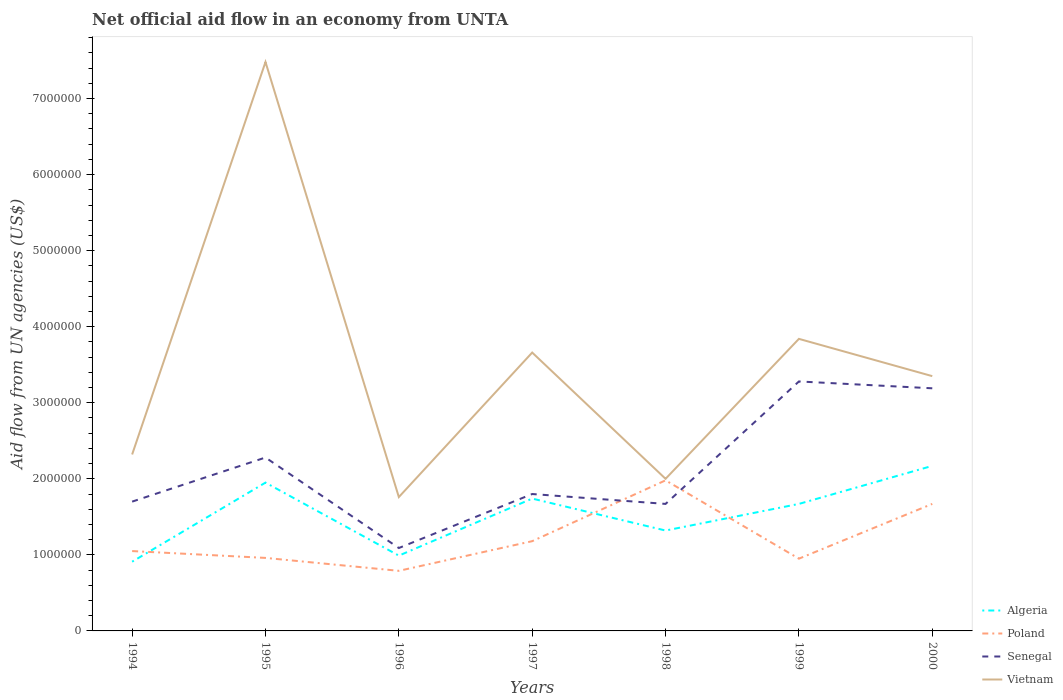Across all years, what is the maximum net official aid flow in Vietnam?
Give a very brief answer. 1.76e+06. In which year was the net official aid flow in Vietnam maximum?
Your answer should be compact. 1996. What is the total net official aid flow in Senegal in the graph?
Provide a short and direct response. -1.58e+06. What is the difference between the highest and the second highest net official aid flow in Algeria?
Offer a very short reply. 1.26e+06. What is the difference between two consecutive major ticks on the Y-axis?
Offer a terse response. 1.00e+06. Are the values on the major ticks of Y-axis written in scientific E-notation?
Offer a terse response. No. Does the graph contain any zero values?
Your response must be concise. No. Where does the legend appear in the graph?
Provide a succinct answer. Bottom right. How are the legend labels stacked?
Provide a succinct answer. Vertical. What is the title of the graph?
Provide a succinct answer. Net official aid flow in an economy from UNTA. What is the label or title of the X-axis?
Offer a very short reply. Years. What is the label or title of the Y-axis?
Keep it short and to the point. Aid flow from UN agencies (US$). What is the Aid flow from UN agencies (US$) of Algeria in 1994?
Ensure brevity in your answer.  9.10e+05. What is the Aid flow from UN agencies (US$) of Poland in 1994?
Give a very brief answer. 1.05e+06. What is the Aid flow from UN agencies (US$) in Senegal in 1994?
Offer a very short reply. 1.70e+06. What is the Aid flow from UN agencies (US$) in Vietnam in 1994?
Ensure brevity in your answer.  2.32e+06. What is the Aid flow from UN agencies (US$) of Algeria in 1995?
Your response must be concise. 1.95e+06. What is the Aid flow from UN agencies (US$) in Poland in 1995?
Offer a terse response. 9.60e+05. What is the Aid flow from UN agencies (US$) in Senegal in 1995?
Offer a very short reply. 2.28e+06. What is the Aid flow from UN agencies (US$) in Vietnam in 1995?
Offer a terse response. 7.48e+06. What is the Aid flow from UN agencies (US$) in Algeria in 1996?
Your answer should be compact. 9.90e+05. What is the Aid flow from UN agencies (US$) of Poland in 1996?
Keep it short and to the point. 7.90e+05. What is the Aid flow from UN agencies (US$) in Senegal in 1996?
Your answer should be very brief. 1.09e+06. What is the Aid flow from UN agencies (US$) of Vietnam in 1996?
Provide a short and direct response. 1.76e+06. What is the Aid flow from UN agencies (US$) of Algeria in 1997?
Offer a terse response. 1.74e+06. What is the Aid flow from UN agencies (US$) in Poland in 1997?
Keep it short and to the point. 1.18e+06. What is the Aid flow from UN agencies (US$) in Senegal in 1997?
Your answer should be very brief. 1.80e+06. What is the Aid flow from UN agencies (US$) in Vietnam in 1997?
Offer a very short reply. 3.66e+06. What is the Aid flow from UN agencies (US$) of Algeria in 1998?
Your answer should be very brief. 1.32e+06. What is the Aid flow from UN agencies (US$) in Poland in 1998?
Make the answer very short. 1.98e+06. What is the Aid flow from UN agencies (US$) of Senegal in 1998?
Give a very brief answer. 1.67e+06. What is the Aid flow from UN agencies (US$) of Algeria in 1999?
Your answer should be compact. 1.67e+06. What is the Aid flow from UN agencies (US$) of Poland in 1999?
Provide a succinct answer. 9.50e+05. What is the Aid flow from UN agencies (US$) in Senegal in 1999?
Keep it short and to the point. 3.28e+06. What is the Aid flow from UN agencies (US$) of Vietnam in 1999?
Provide a succinct answer. 3.84e+06. What is the Aid flow from UN agencies (US$) of Algeria in 2000?
Keep it short and to the point. 2.17e+06. What is the Aid flow from UN agencies (US$) in Poland in 2000?
Make the answer very short. 1.67e+06. What is the Aid flow from UN agencies (US$) of Senegal in 2000?
Ensure brevity in your answer.  3.19e+06. What is the Aid flow from UN agencies (US$) in Vietnam in 2000?
Give a very brief answer. 3.35e+06. Across all years, what is the maximum Aid flow from UN agencies (US$) of Algeria?
Your response must be concise. 2.17e+06. Across all years, what is the maximum Aid flow from UN agencies (US$) of Poland?
Offer a terse response. 1.98e+06. Across all years, what is the maximum Aid flow from UN agencies (US$) of Senegal?
Your answer should be compact. 3.28e+06. Across all years, what is the maximum Aid flow from UN agencies (US$) of Vietnam?
Offer a terse response. 7.48e+06. Across all years, what is the minimum Aid flow from UN agencies (US$) of Algeria?
Your answer should be compact. 9.10e+05. Across all years, what is the minimum Aid flow from UN agencies (US$) in Poland?
Your answer should be compact. 7.90e+05. Across all years, what is the minimum Aid flow from UN agencies (US$) of Senegal?
Your answer should be very brief. 1.09e+06. Across all years, what is the minimum Aid flow from UN agencies (US$) in Vietnam?
Give a very brief answer. 1.76e+06. What is the total Aid flow from UN agencies (US$) in Algeria in the graph?
Make the answer very short. 1.08e+07. What is the total Aid flow from UN agencies (US$) of Poland in the graph?
Ensure brevity in your answer.  8.58e+06. What is the total Aid flow from UN agencies (US$) of Senegal in the graph?
Make the answer very short. 1.50e+07. What is the total Aid flow from UN agencies (US$) in Vietnam in the graph?
Keep it short and to the point. 2.44e+07. What is the difference between the Aid flow from UN agencies (US$) in Algeria in 1994 and that in 1995?
Ensure brevity in your answer.  -1.04e+06. What is the difference between the Aid flow from UN agencies (US$) of Senegal in 1994 and that in 1995?
Provide a short and direct response. -5.80e+05. What is the difference between the Aid flow from UN agencies (US$) of Vietnam in 1994 and that in 1995?
Offer a terse response. -5.16e+06. What is the difference between the Aid flow from UN agencies (US$) in Algeria in 1994 and that in 1996?
Offer a very short reply. -8.00e+04. What is the difference between the Aid flow from UN agencies (US$) of Poland in 1994 and that in 1996?
Provide a short and direct response. 2.60e+05. What is the difference between the Aid flow from UN agencies (US$) in Vietnam in 1994 and that in 1996?
Your answer should be compact. 5.60e+05. What is the difference between the Aid flow from UN agencies (US$) in Algeria in 1994 and that in 1997?
Give a very brief answer. -8.30e+05. What is the difference between the Aid flow from UN agencies (US$) of Poland in 1994 and that in 1997?
Provide a short and direct response. -1.30e+05. What is the difference between the Aid flow from UN agencies (US$) in Vietnam in 1994 and that in 1997?
Keep it short and to the point. -1.34e+06. What is the difference between the Aid flow from UN agencies (US$) of Algeria in 1994 and that in 1998?
Provide a succinct answer. -4.10e+05. What is the difference between the Aid flow from UN agencies (US$) in Poland in 1994 and that in 1998?
Give a very brief answer. -9.30e+05. What is the difference between the Aid flow from UN agencies (US$) of Vietnam in 1994 and that in 1998?
Give a very brief answer. 3.20e+05. What is the difference between the Aid flow from UN agencies (US$) of Algeria in 1994 and that in 1999?
Provide a succinct answer. -7.60e+05. What is the difference between the Aid flow from UN agencies (US$) in Poland in 1994 and that in 1999?
Provide a short and direct response. 1.00e+05. What is the difference between the Aid flow from UN agencies (US$) of Senegal in 1994 and that in 1999?
Ensure brevity in your answer.  -1.58e+06. What is the difference between the Aid flow from UN agencies (US$) of Vietnam in 1994 and that in 1999?
Offer a very short reply. -1.52e+06. What is the difference between the Aid flow from UN agencies (US$) of Algeria in 1994 and that in 2000?
Your answer should be compact. -1.26e+06. What is the difference between the Aid flow from UN agencies (US$) of Poland in 1994 and that in 2000?
Offer a terse response. -6.20e+05. What is the difference between the Aid flow from UN agencies (US$) of Senegal in 1994 and that in 2000?
Keep it short and to the point. -1.49e+06. What is the difference between the Aid flow from UN agencies (US$) in Vietnam in 1994 and that in 2000?
Give a very brief answer. -1.03e+06. What is the difference between the Aid flow from UN agencies (US$) of Algeria in 1995 and that in 1996?
Your answer should be compact. 9.60e+05. What is the difference between the Aid flow from UN agencies (US$) in Poland in 1995 and that in 1996?
Your answer should be compact. 1.70e+05. What is the difference between the Aid flow from UN agencies (US$) in Senegal in 1995 and that in 1996?
Your response must be concise. 1.19e+06. What is the difference between the Aid flow from UN agencies (US$) of Vietnam in 1995 and that in 1996?
Provide a short and direct response. 5.72e+06. What is the difference between the Aid flow from UN agencies (US$) in Algeria in 1995 and that in 1997?
Provide a short and direct response. 2.10e+05. What is the difference between the Aid flow from UN agencies (US$) in Poland in 1995 and that in 1997?
Your response must be concise. -2.20e+05. What is the difference between the Aid flow from UN agencies (US$) of Senegal in 1995 and that in 1997?
Ensure brevity in your answer.  4.80e+05. What is the difference between the Aid flow from UN agencies (US$) of Vietnam in 1995 and that in 1997?
Give a very brief answer. 3.82e+06. What is the difference between the Aid flow from UN agencies (US$) in Algeria in 1995 and that in 1998?
Ensure brevity in your answer.  6.30e+05. What is the difference between the Aid flow from UN agencies (US$) of Poland in 1995 and that in 1998?
Your response must be concise. -1.02e+06. What is the difference between the Aid flow from UN agencies (US$) in Senegal in 1995 and that in 1998?
Make the answer very short. 6.10e+05. What is the difference between the Aid flow from UN agencies (US$) of Vietnam in 1995 and that in 1998?
Ensure brevity in your answer.  5.48e+06. What is the difference between the Aid flow from UN agencies (US$) of Algeria in 1995 and that in 1999?
Your answer should be compact. 2.80e+05. What is the difference between the Aid flow from UN agencies (US$) in Poland in 1995 and that in 1999?
Provide a succinct answer. 10000. What is the difference between the Aid flow from UN agencies (US$) of Vietnam in 1995 and that in 1999?
Your answer should be compact. 3.64e+06. What is the difference between the Aid flow from UN agencies (US$) of Poland in 1995 and that in 2000?
Provide a succinct answer. -7.10e+05. What is the difference between the Aid flow from UN agencies (US$) of Senegal in 1995 and that in 2000?
Ensure brevity in your answer.  -9.10e+05. What is the difference between the Aid flow from UN agencies (US$) in Vietnam in 1995 and that in 2000?
Provide a short and direct response. 4.13e+06. What is the difference between the Aid flow from UN agencies (US$) in Algeria in 1996 and that in 1997?
Offer a terse response. -7.50e+05. What is the difference between the Aid flow from UN agencies (US$) of Poland in 1996 and that in 1997?
Make the answer very short. -3.90e+05. What is the difference between the Aid flow from UN agencies (US$) in Senegal in 1996 and that in 1997?
Offer a very short reply. -7.10e+05. What is the difference between the Aid flow from UN agencies (US$) of Vietnam in 1996 and that in 1997?
Keep it short and to the point. -1.90e+06. What is the difference between the Aid flow from UN agencies (US$) of Algeria in 1996 and that in 1998?
Ensure brevity in your answer.  -3.30e+05. What is the difference between the Aid flow from UN agencies (US$) of Poland in 1996 and that in 1998?
Provide a short and direct response. -1.19e+06. What is the difference between the Aid flow from UN agencies (US$) in Senegal in 1996 and that in 1998?
Offer a terse response. -5.80e+05. What is the difference between the Aid flow from UN agencies (US$) in Algeria in 1996 and that in 1999?
Make the answer very short. -6.80e+05. What is the difference between the Aid flow from UN agencies (US$) of Poland in 1996 and that in 1999?
Provide a succinct answer. -1.60e+05. What is the difference between the Aid flow from UN agencies (US$) of Senegal in 1996 and that in 1999?
Your answer should be very brief. -2.19e+06. What is the difference between the Aid flow from UN agencies (US$) of Vietnam in 1996 and that in 1999?
Offer a very short reply. -2.08e+06. What is the difference between the Aid flow from UN agencies (US$) in Algeria in 1996 and that in 2000?
Provide a succinct answer. -1.18e+06. What is the difference between the Aid flow from UN agencies (US$) of Poland in 1996 and that in 2000?
Give a very brief answer. -8.80e+05. What is the difference between the Aid flow from UN agencies (US$) in Senegal in 1996 and that in 2000?
Offer a terse response. -2.10e+06. What is the difference between the Aid flow from UN agencies (US$) of Vietnam in 1996 and that in 2000?
Make the answer very short. -1.59e+06. What is the difference between the Aid flow from UN agencies (US$) in Poland in 1997 and that in 1998?
Make the answer very short. -8.00e+05. What is the difference between the Aid flow from UN agencies (US$) of Senegal in 1997 and that in 1998?
Offer a very short reply. 1.30e+05. What is the difference between the Aid flow from UN agencies (US$) in Vietnam in 1997 and that in 1998?
Make the answer very short. 1.66e+06. What is the difference between the Aid flow from UN agencies (US$) in Algeria in 1997 and that in 1999?
Provide a short and direct response. 7.00e+04. What is the difference between the Aid flow from UN agencies (US$) of Senegal in 1997 and that in 1999?
Offer a terse response. -1.48e+06. What is the difference between the Aid flow from UN agencies (US$) of Algeria in 1997 and that in 2000?
Provide a short and direct response. -4.30e+05. What is the difference between the Aid flow from UN agencies (US$) of Poland in 1997 and that in 2000?
Your answer should be very brief. -4.90e+05. What is the difference between the Aid flow from UN agencies (US$) in Senegal in 1997 and that in 2000?
Your answer should be compact. -1.39e+06. What is the difference between the Aid flow from UN agencies (US$) in Vietnam in 1997 and that in 2000?
Your response must be concise. 3.10e+05. What is the difference between the Aid flow from UN agencies (US$) of Algeria in 1998 and that in 1999?
Keep it short and to the point. -3.50e+05. What is the difference between the Aid flow from UN agencies (US$) in Poland in 1998 and that in 1999?
Offer a terse response. 1.03e+06. What is the difference between the Aid flow from UN agencies (US$) of Senegal in 1998 and that in 1999?
Your response must be concise. -1.61e+06. What is the difference between the Aid flow from UN agencies (US$) in Vietnam in 1998 and that in 1999?
Provide a succinct answer. -1.84e+06. What is the difference between the Aid flow from UN agencies (US$) in Algeria in 1998 and that in 2000?
Offer a terse response. -8.50e+05. What is the difference between the Aid flow from UN agencies (US$) of Poland in 1998 and that in 2000?
Your answer should be very brief. 3.10e+05. What is the difference between the Aid flow from UN agencies (US$) of Senegal in 1998 and that in 2000?
Offer a terse response. -1.52e+06. What is the difference between the Aid flow from UN agencies (US$) of Vietnam in 1998 and that in 2000?
Give a very brief answer. -1.35e+06. What is the difference between the Aid flow from UN agencies (US$) of Algeria in 1999 and that in 2000?
Offer a very short reply. -5.00e+05. What is the difference between the Aid flow from UN agencies (US$) of Poland in 1999 and that in 2000?
Your answer should be very brief. -7.20e+05. What is the difference between the Aid flow from UN agencies (US$) of Senegal in 1999 and that in 2000?
Give a very brief answer. 9.00e+04. What is the difference between the Aid flow from UN agencies (US$) of Vietnam in 1999 and that in 2000?
Keep it short and to the point. 4.90e+05. What is the difference between the Aid flow from UN agencies (US$) in Algeria in 1994 and the Aid flow from UN agencies (US$) in Poland in 1995?
Give a very brief answer. -5.00e+04. What is the difference between the Aid flow from UN agencies (US$) of Algeria in 1994 and the Aid flow from UN agencies (US$) of Senegal in 1995?
Make the answer very short. -1.37e+06. What is the difference between the Aid flow from UN agencies (US$) in Algeria in 1994 and the Aid flow from UN agencies (US$) in Vietnam in 1995?
Ensure brevity in your answer.  -6.57e+06. What is the difference between the Aid flow from UN agencies (US$) in Poland in 1994 and the Aid flow from UN agencies (US$) in Senegal in 1995?
Provide a succinct answer. -1.23e+06. What is the difference between the Aid flow from UN agencies (US$) of Poland in 1994 and the Aid flow from UN agencies (US$) of Vietnam in 1995?
Ensure brevity in your answer.  -6.43e+06. What is the difference between the Aid flow from UN agencies (US$) of Senegal in 1994 and the Aid flow from UN agencies (US$) of Vietnam in 1995?
Provide a short and direct response. -5.78e+06. What is the difference between the Aid flow from UN agencies (US$) in Algeria in 1994 and the Aid flow from UN agencies (US$) in Vietnam in 1996?
Keep it short and to the point. -8.50e+05. What is the difference between the Aid flow from UN agencies (US$) of Poland in 1994 and the Aid flow from UN agencies (US$) of Vietnam in 1996?
Keep it short and to the point. -7.10e+05. What is the difference between the Aid flow from UN agencies (US$) in Algeria in 1994 and the Aid flow from UN agencies (US$) in Senegal in 1997?
Your response must be concise. -8.90e+05. What is the difference between the Aid flow from UN agencies (US$) of Algeria in 1994 and the Aid flow from UN agencies (US$) of Vietnam in 1997?
Keep it short and to the point. -2.75e+06. What is the difference between the Aid flow from UN agencies (US$) of Poland in 1994 and the Aid flow from UN agencies (US$) of Senegal in 1997?
Provide a succinct answer. -7.50e+05. What is the difference between the Aid flow from UN agencies (US$) of Poland in 1994 and the Aid flow from UN agencies (US$) of Vietnam in 1997?
Give a very brief answer. -2.61e+06. What is the difference between the Aid flow from UN agencies (US$) of Senegal in 1994 and the Aid flow from UN agencies (US$) of Vietnam in 1997?
Your answer should be very brief. -1.96e+06. What is the difference between the Aid flow from UN agencies (US$) of Algeria in 1994 and the Aid flow from UN agencies (US$) of Poland in 1998?
Offer a terse response. -1.07e+06. What is the difference between the Aid flow from UN agencies (US$) of Algeria in 1994 and the Aid flow from UN agencies (US$) of Senegal in 1998?
Make the answer very short. -7.60e+05. What is the difference between the Aid flow from UN agencies (US$) of Algeria in 1994 and the Aid flow from UN agencies (US$) of Vietnam in 1998?
Keep it short and to the point. -1.09e+06. What is the difference between the Aid flow from UN agencies (US$) in Poland in 1994 and the Aid flow from UN agencies (US$) in Senegal in 1998?
Your answer should be very brief. -6.20e+05. What is the difference between the Aid flow from UN agencies (US$) in Poland in 1994 and the Aid flow from UN agencies (US$) in Vietnam in 1998?
Your response must be concise. -9.50e+05. What is the difference between the Aid flow from UN agencies (US$) of Senegal in 1994 and the Aid flow from UN agencies (US$) of Vietnam in 1998?
Your answer should be very brief. -3.00e+05. What is the difference between the Aid flow from UN agencies (US$) of Algeria in 1994 and the Aid flow from UN agencies (US$) of Senegal in 1999?
Offer a terse response. -2.37e+06. What is the difference between the Aid flow from UN agencies (US$) of Algeria in 1994 and the Aid flow from UN agencies (US$) of Vietnam in 1999?
Provide a succinct answer. -2.93e+06. What is the difference between the Aid flow from UN agencies (US$) of Poland in 1994 and the Aid flow from UN agencies (US$) of Senegal in 1999?
Your answer should be compact. -2.23e+06. What is the difference between the Aid flow from UN agencies (US$) of Poland in 1994 and the Aid flow from UN agencies (US$) of Vietnam in 1999?
Give a very brief answer. -2.79e+06. What is the difference between the Aid flow from UN agencies (US$) of Senegal in 1994 and the Aid flow from UN agencies (US$) of Vietnam in 1999?
Offer a terse response. -2.14e+06. What is the difference between the Aid flow from UN agencies (US$) of Algeria in 1994 and the Aid flow from UN agencies (US$) of Poland in 2000?
Offer a terse response. -7.60e+05. What is the difference between the Aid flow from UN agencies (US$) in Algeria in 1994 and the Aid flow from UN agencies (US$) in Senegal in 2000?
Provide a succinct answer. -2.28e+06. What is the difference between the Aid flow from UN agencies (US$) of Algeria in 1994 and the Aid flow from UN agencies (US$) of Vietnam in 2000?
Offer a terse response. -2.44e+06. What is the difference between the Aid flow from UN agencies (US$) in Poland in 1994 and the Aid flow from UN agencies (US$) in Senegal in 2000?
Provide a succinct answer. -2.14e+06. What is the difference between the Aid flow from UN agencies (US$) in Poland in 1994 and the Aid flow from UN agencies (US$) in Vietnam in 2000?
Ensure brevity in your answer.  -2.30e+06. What is the difference between the Aid flow from UN agencies (US$) of Senegal in 1994 and the Aid flow from UN agencies (US$) of Vietnam in 2000?
Provide a succinct answer. -1.65e+06. What is the difference between the Aid flow from UN agencies (US$) in Algeria in 1995 and the Aid flow from UN agencies (US$) in Poland in 1996?
Make the answer very short. 1.16e+06. What is the difference between the Aid flow from UN agencies (US$) of Algeria in 1995 and the Aid flow from UN agencies (US$) of Senegal in 1996?
Your answer should be very brief. 8.60e+05. What is the difference between the Aid flow from UN agencies (US$) in Algeria in 1995 and the Aid flow from UN agencies (US$) in Vietnam in 1996?
Your answer should be very brief. 1.90e+05. What is the difference between the Aid flow from UN agencies (US$) in Poland in 1995 and the Aid flow from UN agencies (US$) in Vietnam in 1996?
Provide a short and direct response. -8.00e+05. What is the difference between the Aid flow from UN agencies (US$) of Senegal in 1995 and the Aid flow from UN agencies (US$) of Vietnam in 1996?
Give a very brief answer. 5.20e+05. What is the difference between the Aid flow from UN agencies (US$) of Algeria in 1995 and the Aid flow from UN agencies (US$) of Poland in 1997?
Provide a succinct answer. 7.70e+05. What is the difference between the Aid flow from UN agencies (US$) of Algeria in 1995 and the Aid flow from UN agencies (US$) of Senegal in 1997?
Offer a terse response. 1.50e+05. What is the difference between the Aid flow from UN agencies (US$) in Algeria in 1995 and the Aid flow from UN agencies (US$) in Vietnam in 1997?
Keep it short and to the point. -1.71e+06. What is the difference between the Aid flow from UN agencies (US$) in Poland in 1995 and the Aid flow from UN agencies (US$) in Senegal in 1997?
Ensure brevity in your answer.  -8.40e+05. What is the difference between the Aid flow from UN agencies (US$) in Poland in 1995 and the Aid flow from UN agencies (US$) in Vietnam in 1997?
Offer a terse response. -2.70e+06. What is the difference between the Aid flow from UN agencies (US$) in Senegal in 1995 and the Aid flow from UN agencies (US$) in Vietnam in 1997?
Make the answer very short. -1.38e+06. What is the difference between the Aid flow from UN agencies (US$) in Algeria in 1995 and the Aid flow from UN agencies (US$) in Senegal in 1998?
Provide a succinct answer. 2.80e+05. What is the difference between the Aid flow from UN agencies (US$) in Algeria in 1995 and the Aid flow from UN agencies (US$) in Vietnam in 1998?
Your response must be concise. -5.00e+04. What is the difference between the Aid flow from UN agencies (US$) of Poland in 1995 and the Aid flow from UN agencies (US$) of Senegal in 1998?
Provide a short and direct response. -7.10e+05. What is the difference between the Aid flow from UN agencies (US$) of Poland in 1995 and the Aid flow from UN agencies (US$) of Vietnam in 1998?
Your response must be concise. -1.04e+06. What is the difference between the Aid flow from UN agencies (US$) in Algeria in 1995 and the Aid flow from UN agencies (US$) in Senegal in 1999?
Make the answer very short. -1.33e+06. What is the difference between the Aid flow from UN agencies (US$) in Algeria in 1995 and the Aid flow from UN agencies (US$) in Vietnam in 1999?
Your answer should be very brief. -1.89e+06. What is the difference between the Aid flow from UN agencies (US$) of Poland in 1995 and the Aid flow from UN agencies (US$) of Senegal in 1999?
Provide a succinct answer. -2.32e+06. What is the difference between the Aid flow from UN agencies (US$) in Poland in 1995 and the Aid flow from UN agencies (US$) in Vietnam in 1999?
Offer a terse response. -2.88e+06. What is the difference between the Aid flow from UN agencies (US$) in Senegal in 1995 and the Aid flow from UN agencies (US$) in Vietnam in 1999?
Provide a succinct answer. -1.56e+06. What is the difference between the Aid flow from UN agencies (US$) of Algeria in 1995 and the Aid flow from UN agencies (US$) of Poland in 2000?
Your answer should be compact. 2.80e+05. What is the difference between the Aid flow from UN agencies (US$) of Algeria in 1995 and the Aid flow from UN agencies (US$) of Senegal in 2000?
Your response must be concise. -1.24e+06. What is the difference between the Aid flow from UN agencies (US$) of Algeria in 1995 and the Aid flow from UN agencies (US$) of Vietnam in 2000?
Keep it short and to the point. -1.40e+06. What is the difference between the Aid flow from UN agencies (US$) of Poland in 1995 and the Aid flow from UN agencies (US$) of Senegal in 2000?
Provide a succinct answer. -2.23e+06. What is the difference between the Aid flow from UN agencies (US$) of Poland in 1995 and the Aid flow from UN agencies (US$) of Vietnam in 2000?
Provide a succinct answer. -2.39e+06. What is the difference between the Aid flow from UN agencies (US$) of Senegal in 1995 and the Aid flow from UN agencies (US$) of Vietnam in 2000?
Offer a terse response. -1.07e+06. What is the difference between the Aid flow from UN agencies (US$) of Algeria in 1996 and the Aid flow from UN agencies (US$) of Senegal in 1997?
Your answer should be very brief. -8.10e+05. What is the difference between the Aid flow from UN agencies (US$) in Algeria in 1996 and the Aid flow from UN agencies (US$) in Vietnam in 1997?
Keep it short and to the point. -2.67e+06. What is the difference between the Aid flow from UN agencies (US$) of Poland in 1996 and the Aid flow from UN agencies (US$) of Senegal in 1997?
Offer a very short reply. -1.01e+06. What is the difference between the Aid flow from UN agencies (US$) of Poland in 1996 and the Aid flow from UN agencies (US$) of Vietnam in 1997?
Ensure brevity in your answer.  -2.87e+06. What is the difference between the Aid flow from UN agencies (US$) of Senegal in 1996 and the Aid flow from UN agencies (US$) of Vietnam in 1997?
Keep it short and to the point. -2.57e+06. What is the difference between the Aid flow from UN agencies (US$) in Algeria in 1996 and the Aid flow from UN agencies (US$) in Poland in 1998?
Offer a terse response. -9.90e+05. What is the difference between the Aid flow from UN agencies (US$) of Algeria in 1996 and the Aid flow from UN agencies (US$) of Senegal in 1998?
Make the answer very short. -6.80e+05. What is the difference between the Aid flow from UN agencies (US$) of Algeria in 1996 and the Aid flow from UN agencies (US$) of Vietnam in 1998?
Offer a very short reply. -1.01e+06. What is the difference between the Aid flow from UN agencies (US$) in Poland in 1996 and the Aid flow from UN agencies (US$) in Senegal in 1998?
Your answer should be very brief. -8.80e+05. What is the difference between the Aid flow from UN agencies (US$) in Poland in 1996 and the Aid flow from UN agencies (US$) in Vietnam in 1998?
Keep it short and to the point. -1.21e+06. What is the difference between the Aid flow from UN agencies (US$) in Senegal in 1996 and the Aid flow from UN agencies (US$) in Vietnam in 1998?
Your answer should be very brief. -9.10e+05. What is the difference between the Aid flow from UN agencies (US$) in Algeria in 1996 and the Aid flow from UN agencies (US$) in Poland in 1999?
Make the answer very short. 4.00e+04. What is the difference between the Aid flow from UN agencies (US$) in Algeria in 1996 and the Aid flow from UN agencies (US$) in Senegal in 1999?
Offer a terse response. -2.29e+06. What is the difference between the Aid flow from UN agencies (US$) of Algeria in 1996 and the Aid flow from UN agencies (US$) of Vietnam in 1999?
Offer a terse response. -2.85e+06. What is the difference between the Aid flow from UN agencies (US$) in Poland in 1996 and the Aid flow from UN agencies (US$) in Senegal in 1999?
Offer a terse response. -2.49e+06. What is the difference between the Aid flow from UN agencies (US$) in Poland in 1996 and the Aid flow from UN agencies (US$) in Vietnam in 1999?
Provide a succinct answer. -3.05e+06. What is the difference between the Aid flow from UN agencies (US$) in Senegal in 1996 and the Aid flow from UN agencies (US$) in Vietnam in 1999?
Ensure brevity in your answer.  -2.75e+06. What is the difference between the Aid flow from UN agencies (US$) in Algeria in 1996 and the Aid flow from UN agencies (US$) in Poland in 2000?
Provide a short and direct response. -6.80e+05. What is the difference between the Aid flow from UN agencies (US$) of Algeria in 1996 and the Aid flow from UN agencies (US$) of Senegal in 2000?
Make the answer very short. -2.20e+06. What is the difference between the Aid flow from UN agencies (US$) of Algeria in 1996 and the Aid flow from UN agencies (US$) of Vietnam in 2000?
Provide a short and direct response. -2.36e+06. What is the difference between the Aid flow from UN agencies (US$) of Poland in 1996 and the Aid flow from UN agencies (US$) of Senegal in 2000?
Make the answer very short. -2.40e+06. What is the difference between the Aid flow from UN agencies (US$) of Poland in 1996 and the Aid flow from UN agencies (US$) of Vietnam in 2000?
Offer a very short reply. -2.56e+06. What is the difference between the Aid flow from UN agencies (US$) in Senegal in 1996 and the Aid flow from UN agencies (US$) in Vietnam in 2000?
Give a very brief answer. -2.26e+06. What is the difference between the Aid flow from UN agencies (US$) in Algeria in 1997 and the Aid flow from UN agencies (US$) in Poland in 1998?
Give a very brief answer. -2.40e+05. What is the difference between the Aid flow from UN agencies (US$) in Poland in 1997 and the Aid flow from UN agencies (US$) in Senegal in 1998?
Your answer should be very brief. -4.90e+05. What is the difference between the Aid flow from UN agencies (US$) of Poland in 1997 and the Aid flow from UN agencies (US$) of Vietnam in 1998?
Your answer should be compact. -8.20e+05. What is the difference between the Aid flow from UN agencies (US$) in Algeria in 1997 and the Aid flow from UN agencies (US$) in Poland in 1999?
Offer a very short reply. 7.90e+05. What is the difference between the Aid flow from UN agencies (US$) in Algeria in 1997 and the Aid flow from UN agencies (US$) in Senegal in 1999?
Your answer should be compact. -1.54e+06. What is the difference between the Aid flow from UN agencies (US$) in Algeria in 1997 and the Aid flow from UN agencies (US$) in Vietnam in 1999?
Your answer should be very brief. -2.10e+06. What is the difference between the Aid flow from UN agencies (US$) of Poland in 1997 and the Aid flow from UN agencies (US$) of Senegal in 1999?
Ensure brevity in your answer.  -2.10e+06. What is the difference between the Aid flow from UN agencies (US$) in Poland in 1997 and the Aid flow from UN agencies (US$) in Vietnam in 1999?
Offer a very short reply. -2.66e+06. What is the difference between the Aid flow from UN agencies (US$) in Senegal in 1997 and the Aid flow from UN agencies (US$) in Vietnam in 1999?
Keep it short and to the point. -2.04e+06. What is the difference between the Aid flow from UN agencies (US$) of Algeria in 1997 and the Aid flow from UN agencies (US$) of Senegal in 2000?
Your answer should be compact. -1.45e+06. What is the difference between the Aid flow from UN agencies (US$) in Algeria in 1997 and the Aid flow from UN agencies (US$) in Vietnam in 2000?
Provide a succinct answer. -1.61e+06. What is the difference between the Aid flow from UN agencies (US$) of Poland in 1997 and the Aid flow from UN agencies (US$) of Senegal in 2000?
Your answer should be compact. -2.01e+06. What is the difference between the Aid flow from UN agencies (US$) in Poland in 1997 and the Aid flow from UN agencies (US$) in Vietnam in 2000?
Offer a very short reply. -2.17e+06. What is the difference between the Aid flow from UN agencies (US$) in Senegal in 1997 and the Aid flow from UN agencies (US$) in Vietnam in 2000?
Offer a very short reply. -1.55e+06. What is the difference between the Aid flow from UN agencies (US$) in Algeria in 1998 and the Aid flow from UN agencies (US$) in Senegal in 1999?
Your answer should be very brief. -1.96e+06. What is the difference between the Aid flow from UN agencies (US$) in Algeria in 1998 and the Aid flow from UN agencies (US$) in Vietnam in 1999?
Offer a terse response. -2.52e+06. What is the difference between the Aid flow from UN agencies (US$) of Poland in 1998 and the Aid flow from UN agencies (US$) of Senegal in 1999?
Make the answer very short. -1.30e+06. What is the difference between the Aid flow from UN agencies (US$) in Poland in 1998 and the Aid flow from UN agencies (US$) in Vietnam in 1999?
Your answer should be very brief. -1.86e+06. What is the difference between the Aid flow from UN agencies (US$) in Senegal in 1998 and the Aid flow from UN agencies (US$) in Vietnam in 1999?
Provide a short and direct response. -2.17e+06. What is the difference between the Aid flow from UN agencies (US$) of Algeria in 1998 and the Aid flow from UN agencies (US$) of Poland in 2000?
Provide a succinct answer. -3.50e+05. What is the difference between the Aid flow from UN agencies (US$) of Algeria in 1998 and the Aid flow from UN agencies (US$) of Senegal in 2000?
Offer a very short reply. -1.87e+06. What is the difference between the Aid flow from UN agencies (US$) in Algeria in 1998 and the Aid flow from UN agencies (US$) in Vietnam in 2000?
Provide a short and direct response. -2.03e+06. What is the difference between the Aid flow from UN agencies (US$) in Poland in 1998 and the Aid flow from UN agencies (US$) in Senegal in 2000?
Provide a short and direct response. -1.21e+06. What is the difference between the Aid flow from UN agencies (US$) of Poland in 1998 and the Aid flow from UN agencies (US$) of Vietnam in 2000?
Offer a very short reply. -1.37e+06. What is the difference between the Aid flow from UN agencies (US$) of Senegal in 1998 and the Aid flow from UN agencies (US$) of Vietnam in 2000?
Keep it short and to the point. -1.68e+06. What is the difference between the Aid flow from UN agencies (US$) in Algeria in 1999 and the Aid flow from UN agencies (US$) in Senegal in 2000?
Give a very brief answer. -1.52e+06. What is the difference between the Aid flow from UN agencies (US$) of Algeria in 1999 and the Aid flow from UN agencies (US$) of Vietnam in 2000?
Your answer should be compact. -1.68e+06. What is the difference between the Aid flow from UN agencies (US$) of Poland in 1999 and the Aid flow from UN agencies (US$) of Senegal in 2000?
Give a very brief answer. -2.24e+06. What is the difference between the Aid flow from UN agencies (US$) in Poland in 1999 and the Aid flow from UN agencies (US$) in Vietnam in 2000?
Offer a very short reply. -2.40e+06. What is the average Aid flow from UN agencies (US$) of Algeria per year?
Your answer should be very brief. 1.54e+06. What is the average Aid flow from UN agencies (US$) in Poland per year?
Provide a succinct answer. 1.23e+06. What is the average Aid flow from UN agencies (US$) of Senegal per year?
Keep it short and to the point. 2.14e+06. What is the average Aid flow from UN agencies (US$) in Vietnam per year?
Your response must be concise. 3.49e+06. In the year 1994, what is the difference between the Aid flow from UN agencies (US$) of Algeria and Aid flow from UN agencies (US$) of Poland?
Your answer should be compact. -1.40e+05. In the year 1994, what is the difference between the Aid flow from UN agencies (US$) in Algeria and Aid flow from UN agencies (US$) in Senegal?
Offer a terse response. -7.90e+05. In the year 1994, what is the difference between the Aid flow from UN agencies (US$) of Algeria and Aid flow from UN agencies (US$) of Vietnam?
Provide a short and direct response. -1.41e+06. In the year 1994, what is the difference between the Aid flow from UN agencies (US$) in Poland and Aid flow from UN agencies (US$) in Senegal?
Make the answer very short. -6.50e+05. In the year 1994, what is the difference between the Aid flow from UN agencies (US$) of Poland and Aid flow from UN agencies (US$) of Vietnam?
Provide a short and direct response. -1.27e+06. In the year 1994, what is the difference between the Aid flow from UN agencies (US$) in Senegal and Aid flow from UN agencies (US$) in Vietnam?
Give a very brief answer. -6.20e+05. In the year 1995, what is the difference between the Aid flow from UN agencies (US$) of Algeria and Aid flow from UN agencies (US$) of Poland?
Make the answer very short. 9.90e+05. In the year 1995, what is the difference between the Aid flow from UN agencies (US$) in Algeria and Aid flow from UN agencies (US$) in Senegal?
Provide a short and direct response. -3.30e+05. In the year 1995, what is the difference between the Aid flow from UN agencies (US$) of Algeria and Aid flow from UN agencies (US$) of Vietnam?
Your answer should be compact. -5.53e+06. In the year 1995, what is the difference between the Aid flow from UN agencies (US$) in Poland and Aid flow from UN agencies (US$) in Senegal?
Keep it short and to the point. -1.32e+06. In the year 1995, what is the difference between the Aid flow from UN agencies (US$) in Poland and Aid flow from UN agencies (US$) in Vietnam?
Your answer should be very brief. -6.52e+06. In the year 1995, what is the difference between the Aid flow from UN agencies (US$) in Senegal and Aid flow from UN agencies (US$) in Vietnam?
Your response must be concise. -5.20e+06. In the year 1996, what is the difference between the Aid flow from UN agencies (US$) in Algeria and Aid flow from UN agencies (US$) in Poland?
Provide a short and direct response. 2.00e+05. In the year 1996, what is the difference between the Aid flow from UN agencies (US$) of Algeria and Aid flow from UN agencies (US$) of Vietnam?
Ensure brevity in your answer.  -7.70e+05. In the year 1996, what is the difference between the Aid flow from UN agencies (US$) of Poland and Aid flow from UN agencies (US$) of Vietnam?
Offer a very short reply. -9.70e+05. In the year 1996, what is the difference between the Aid flow from UN agencies (US$) of Senegal and Aid flow from UN agencies (US$) of Vietnam?
Provide a succinct answer. -6.70e+05. In the year 1997, what is the difference between the Aid flow from UN agencies (US$) of Algeria and Aid flow from UN agencies (US$) of Poland?
Your answer should be compact. 5.60e+05. In the year 1997, what is the difference between the Aid flow from UN agencies (US$) in Algeria and Aid flow from UN agencies (US$) in Senegal?
Give a very brief answer. -6.00e+04. In the year 1997, what is the difference between the Aid flow from UN agencies (US$) of Algeria and Aid flow from UN agencies (US$) of Vietnam?
Your response must be concise. -1.92e+06. In the year 1997, what is the difference between the Aid flow from UN agencies (US$) of Poland and Aid flow from UN agencies (US$) of Senegal?
Ensure brevity in your answer.  -6.20e+05. In the year 1997, what is the difference between the Aid flow from UN agencies (US$) of Poland and Aid flow from UN agencies (US$) of Vietnam?
Provide a short and direct response. -2.48e+06. In the year 1997, what is the difference between the Aid flow from UN agencies (US$) of Senegal and Aid flow from UN agencies (US$) of Vietnam?
Your answer should be very brief. -1.86e+06. In the year 1998, what is the difference between the Aid flow from UN agencies (US$) in Algeria and Aid flow from UN agencies (US$) in Poland?
Make the answer very short. -6.60e+05. In the year 1998, what is the difference between the Aid flow from UN agencies (US$) in Algeria and Aid flow from UN agencies (US$) in Senegal?
Provide a short and direct response. -3.50e+05. In the year 1998, what is the difference between the Aid flow from UN agencies (US$) of Algeria and Aid flow from UN agencies (US$) of Vietnam?
Your answer should be very brief. -6.80e+05. In the year 1998, what is the difference between the Aid flow from UN agencies (US$) of Poland and Aid flow from UN agencies (US$) of Vietnam?
Your answer should be very brief. -2.00e+04. In the year 1998, what is the difference between the Aid flow from UN agencies (US$) in Senegal and Aid flow from UN agencies (US$) in Vietnam?
Provide a short and direct response. -3.30e+05. In the year 1999, what is the difference between the Aid flow from UN agencies (US$) in Algeria and Aid flow from UN agencies (US$) in Poland?
Make the answer very short. 7.20e+05. In the year 1999, what is the difference between the Aid flow from UN agencies (US$) in Algeria and Aid flow from UN agencies (US$) in Senegal?
Offer a very short reply. -1.61e+06. In the year 1999, what is the difference between the Aid flow from UN agencies (US$) of Algeria and Aid flow from UN agencies (US$) of Vietnam?
Keep it short and to the point. -2.17e+06. In the year 1999, what is the difference between the Aid flow from UN agencies (US$) of Poland and Aid flow from UN agencies (US$) of Senegal?
Give a very brief answer. -2.33e+06. In the year 1999, what is the difference between the Aid flow from UN agencies (US$) in Poland and Aid flow from UN agencies (US$) in Vietnam?
Your response must be concise. -2.89e+06. In the year 1999, what is the difference between the Aid flow from UN agencies (US$) of Senegal and Aid flow from UN agencies (US$) of Vietnam?
Offer a very short reply. -5.60e+05. In the year 2000, what is the difference between the Aid flow from UN agencies (US$) of Algeria and Aid flow from UN agencies (US$) of Poland?
Keep it short and to the point. 5.00e+05. In the year 2000, what is the difference between the Aid flow from UN agencies (US$) in Algeria and Aid flow from UN agencies (US$) in Senegal?
Offer a terse response. -1.02e+06. In the year 2000, what is the difference between the Aid flow from UN agencies (US$) of Algeria and Aid flow from UN agencies (US$) of Vietnam?
Your answer should be compact. -1.18e+06. In the year 2000, what is the difference between the Aid flow from UN agencies (US$) of Poland and Aid flow from UN agencies (US$) of Senegal?
Provide a short and direct response. -1.52e+06. In the year 2000, what is the difference between the Aid flow from UN agencies (US$) in Poland and Aid flow from UN agencies (US$) in Vietnam?
Ensure brevity in your answer.  -1.68e+06. In the year 2000, what is the difference between the Aid flow from UN agencies (US$) in Senegal and Aid flow from UN agencies (US$) in Vietnam?
Make the answer very short. -1.60e+05. What is the ratio of the Aid flow from UN agencies (US$) of Algeria in 1994 to that in 1995?
Offer a very short reply. 0.47. What is the ratio of the Aid flow from UN agencies (US$) in Poland in 1994 to that in 1995?
Provide a short and direct response. 1.09. What is the ratio of the Aid flow from UN agencies (US$) of Senegal in 1994 to that in 1995?
Give a very brief answer. 0.75. What is the ratio of the Aid flow from UN agencies (US$) in Vietnam in 1994 to that in 1995?
Your answer should be compact. 0.31. What is the ratio of the Aid flow from UN agencies (US$) in Algeria in 1994 to that in 1996?
Ensure brevity in your answer.  0.92. What is the ratio of the Aid flow from UN agencies (US$) of Poland in 1994 to that in 1996?
Make the answer very short. 1.33. What is the ratio of the Aid flow from UN agencies (US$) of Senegal in 1994 to that in 1996?
Keep it short and to the point. 1.56. What is the ratio of the Aid flow from UN agencies (US$) of Vietnam in 1994 to that in 1996?
Offer a very short reply. 1.32. What is the ratio of the Aid flow from UN agencies (US$) in Algeria in 1994 to that in 1997?
Your response must be concise. 0.52. What is the ratio of the Aid flow from UN agencies (US$) of Poland in 1994 to that in 1997?
Keep it short and to the point. 0.89. What is the ratio of the Aid flow from UN agencies (US$) of Senegal in 1994 to that in 1997?
Keep it short and to the point. 0.94. What is the ratio of the Aid flow from UN agencies (US$) in Vietnam in 1994 to that in 1997?
Ensure brevity in your answer.  0.63. What is the ratio of the Aid flow from UN agencies (US$) in Algeria in 1994 to that in 1998?
Give a very brief answer. 0.69. What is the ratio of the Aid flow from UN agencies (US$) in Poland in 1994 to that in 1998?
Your answer should be very brief. 0.53. What is the ratio of the Aid flow from UN agencies (US$) in Vietnam in 1994 to that in 1998?
Give a very brief answer. 1.16. What is the ratio of the Aid flow from UN agencies (US$) in Algeria in 1994 to that in 1999?
Provide a short and direct response. 0.54. What is the ratio of the Aid flow from UN agencies (US$) of Poland in 1994 to that in 1999?
Keep it short and to the point. 1.11. What is the ratio of the Aid flow from UN agencies (US$) in Senegal in 1994 to that in 1999?
Keep it short and to the point. 0.52. What is the ratio of the Aid flow from UN agencies (US$) of Vietnam in 1994 to that in 1999?
Provide a short and direct response. 0.6. What is the ratio of the Aid flow from UN agencies (US$) of Algeria in 1994 to that in 2000?
Ensure brevity in your answer.  0.42. What is the ratio of the Aid flow from UN agencies (US$) in Poland in 1994 to that in 2000?
Your response must be concise. 0.63. What is the ratio of the Aid flow from UN agencies (US$) in Senegal in 1994 to that in 2000?
Ensure brevity in your answer.  0.53. What is the ratio of the Aid flow from UN agencies (US$) of Vietnam in 1994 to that in 2000?
Your response must be concise. 0.69. What is the ratio of the Aid flow from UN agencies (US$) of Algeria in 1995 to that in 1996?
Offer a very short reply. 1.97. What is the ratio of the Aid flow from UN agencies (US$) in Poland in 1995 to that in 1996?
Provide a short and direct response. 1.22. What is the ratio of the Aid flow from UN agencies (US$) of Senegal in 1995 to that in 1996?
Ensure brevity in your answer.  2.09. What is the ratio of the Aid flow from UN agencies (US$) in Vietnam in 1995 to that in 1996?
Your answer should be compact. 4.25. What is the ratio of the Aid flow from UN agencies (US$) in Algeria in 1995 to that in 1997?
Your answer should be compact. 1.12. What is the ratio of the Aid flow from UN agencies (US$) of Poland in 1995 to that in 1997?
Offer a very short reply. 0.81. What is the ratio of the Aid flow from UN agencies (US$) in Senegal in 1995 to that in 1997?
Your response must be concise. 1.27. What is the ratio of the Aid flow from UN agencies (US$) of Vietnam in 1995 to that in 1997?
Give a very brief answer. 2.04. What is the ratio of the Aid flow from UN agencies (US$) of Algeria in 1995 to that in 1998?
Keep it short and to the point. 1.48. What is the ratio of the Aid flow from UN agencies (US$) of Poland in 1995 to that in 1998?
Offer a very short reply. 0.48. What is the ratio of the Aid flow from UN agencies (US$) of Senegal in 1995 to that in 1998?
Your answer should be compact. 1.37. What is the ratio of the Aid flow from UN agencies (US$) in Vietnam in 1995 to that in 1998?
Keep it short and to the point. 3.74. What is the ratio of the Aid flow from UN agencies (US$) of Algeria in 1995 to that in 1999?
Offer a terse response. 1.17. What is the ratio of the Aid flow from UN agencies (US$) in Poland in 1995 to that in 1999?
Keep it short and to the point. 1.01. What is the ratio of the Aid flow from UN agencies (US$) in Senegal in 1995 to that in 1999?
Your answer should be very brief. 0.7. What is the ratio of the Aid flow from UN agencies (US$) in Vietnam in 1995 to that in 1999?
Your response must be concise. 1.95. What is the ratio of the Aid flow from UN agencies (US$) in Algeria in 1995 to that in 2000?
Make the answer very short. 0.9. What is the ratio of the Aid flow from UN agencies (US$) in Poland in 1995 to that in 2000?
Provide a succinct answer. 0.57. What is the ratio of the Aid flow from UN agencies (US$) of Senegal in 1995 to that in 2000?
Provide a succinct answer. 0.71. What is the ratio of the Aid flow from UN agencies (US$) of Vietnam in 1995 to that in 2000?
Your answer should be very brief. 2.23. What is the ratio of the Aid flow from UN agencies (US$) in Algeria in 1996 to that in 1997?
Your response must be concise. 0.57. What is the ratio of the Aid flow from UN agencies (US$) in Poland in 1996 to that in 1997?
Your answer should be very brief. 0.67. What is the ratio of the Aid flow from UN agencies (US$) of Senegal in 1996 to that in 1997?
Your response must be concise. 0.61. What is the ratio of the Aid flow from UN agencies (US$) in Vietnam in 1996 to that in 1997?
Provide a short and direct response. 0.48. What is the ratio of the Aid flow from UN agencies (US$) of Algeria in 1996 to that in 1998?
Provide a short and direct response. 0.75. What is the ratio of the Aid flow from UN agencies (US$) in Poland in 1996 to that in 1998?
Offer a terse response. 0.4. What is the ratio of the Aid flow from UN agencies (US$) of Senegal in 1996 to that in 1998?
Keep it short and to the point. 0.65. What is the ratio of the Aid flow from UN agencies (US$) of Vietnam in 1996 to that in 1998?
Provide a succinct answer. 0.88. What is the ratio of the Aid flow from UN agencies (US$) of Algeria in 1996 to that in 1999?
Provide a short and direct response. 0.59. What is the ratio of the Aid flow from UN agencies (US$) of Poland in 1996 to that in 1999?
Your response must be concise. 0.83. What is the ratio of the Aid flow from UN agencies (US$) of Senegal in 1996 to that in 1999?
Your answer should be very brief. 0.33. What is the ratio of the Aid flow from UN agencies (US$) of Vietnam in 1996 to that in 1999?
Provide a succinct answer. 0.46. What is the ratio of the Aid flow from UN agencies (US$) in Algeria in 1996 to that in 2000?
Ensure brevity in your answer.  0.46. What is the ratio of the Aid flow from UN agencies (US$) in Poland in 1996 to that in 2000?
Keep it short and to the point. 0.47. What is the ratio of the Aid flow from UN agencies (US$) of Senegal in 1996 to that in 2000?
Your response must be concise. 0.34. What is the ratio of the Aid flow from UN agencies (US$) of Vietnam in 1996 to that in 2000?
Provide a short and direct response. 0.53. What is the ratio of the Aid flow from UN agencies (US$) in Algeria in 1997 to that in 1998?
Ensure brevity in your answer.  1.32. What is the ratio of the Aid flow from UN agencies (US$) of Poland in 1997 to that in 1998?
Keep it short and to the point. 0.6. What is the ratio of the Aid flow from UN agencies (US$) of Senegal in 1997 to that in 1998?
Keep it short and to the point. 1.08. What is the ratio of the Aid flow from UN agencies (US$) in Vietnam in 1997 to that in 1998?
Your response must be concise. 1.83. What is the ratio of the Aid flow from UN agencies (US$) of Algeria in 1997 to that in 1999?
Ensure brevity in your answer.  1.04. What is the ratio of the Aid flow from UN agencies (US$) in Poland in 1997 to that in 1999?
Provide a succinct answer. 1.24. What is the ratio of the Aid flow from UN agencies (US$) in Senegal in 1997 to that in 1999?
Give a very brief answer. 0.55. What is the ratio of the Aid flow from UN agencies (US$) in Vietnam in 1997 to that in 1999?
Provide a short and direct response. 0.95. What is the ratio of the Aid flow from UN agencies (US$) in Algeria in 1997 to that in 2000?
Your response must be concise. 0.8. What is the ratio of the Aid flow from UN agencies (US$) of Poland in 1997 to that in 2000?
Offer a very short reply. 0.71. What is the ratio of the Aid flow from UN agencies (US$) in Senegal in 1997 to that in 2000?
Ensure brevity in your answer.  0.56. What is the ratio of the Aid flow from UN agencies (US$) in Vietnam in 1997 to that in 2000?
Your answer should be very brief. 1.09. What is the ratio of the Aid flow from UN agencies (US$) in Algeria in 1998 to that in 1999?
Your response must be concise. 0.79. What is the ratio of the Aid flow from UN agencies (US$) of Poland in 1998 to that in 1999?
Provide a succinct answer. 2.08. What is the ratio of the Aid flow from UN agencies (US$) in Senegal in 1998 to that in 1999?
Provide a short and direct response. 0.51. What is the ratio of the Aid flow from UN agencies (US$) in Vietnam in 1998 to that in 1999?
Make the answer very short. 0.52. What is the ratio of the Aid flow from UN agencies (US$) of Algeria in 1998 to that in 2000?
Offer a terse response. 0.61. What is the ratio of the Aid flow from UN agencies (US$) of Poland in 1998 to that in 2000?
Your answer should be compact. 1.19. What is the ratio of the Aid flow from UN agencies (US$) of Senegal in 1998 to that in 2000?
Make the answer very short. 0.52. What is the ratio of the Aid flow from UN agencies (US$) in Vietnam in 1998 to that in 2000?
Your response must be concise. 0.6. What is the ratio of the Aid flow from UN agencies (US$) of Algeria in 1999 to that in 2000?
Provide a succinct answer. 0.77. What is the ratio of the Aid flow from UN agencies (US$) of Poland in 1999 to that in 2000?
Your response must be concise. 0.57. What is the ratio of the Aid flow from UN agencies (US$) of Senegal in 1999 to that in 2000?
Ensure brevity in your answer.  1.03. What is the ratio of the Aid flow from UN agencies (US$) of Vietnam in 1999 to that in 2000?
Keep it short and to the point. 1.15. What is the difference between the highest and the second highest Aid flow from UN agencies (US$) of Senegal?
Make the answer very short. 9.00e+04. What is the difference between the highest and the second highest Aid flow from UN agencies (US$) in Vietnam?
Give a very brief answer. 3.64e+06. What is the difference between the highest and the lowest Aid flow from UN agencies (US$) in Algeria?
Your answer should be very brief. 1.26e+06. What is the difference between the highest and the lowest Aid flow from UN agencies (US$) of Poland?
Ensure brevity in your answer.  1.19e+06. What is the difference between the highest and the lowest Aid flow from UN agencies (US$) of Senegal?
Provide a succinct answer. 2.19e+06. What is the difference between the highest and the lowest Aid flow from UN agencies (US$) in Vietnam?
Offer a terse response. 5.72e+06. 